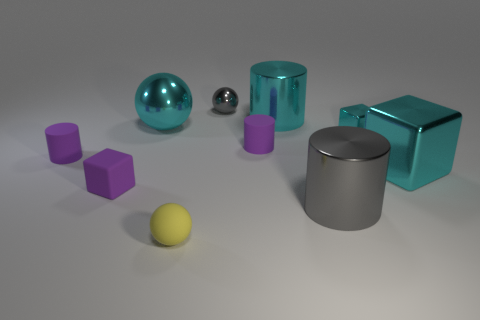Subtract all cyan balls. How many balls are left? 2 Subtract 2 cubes. How many cubes are left? 1 Subtract all cyan blocks. How many blocks are left? 1 Subtract all spheres. How many objects are left? 7 Subtract all cyan cubes. Subtract all matte cylinders. How many objects are left? 6 Add 5 tiny blocks. How many tiny blocks are left? 7 Add 6 tiny brown rubber things. How many tiny brown rubber things exist? 6 Subtract 0 red spheres. How many objects are left? 10 Subtract all gray cylinders. Subtract all cyan blocks. How many cylinders are left? 3 Subtract all gray cylinders. How many yellow spheres are left? 1 